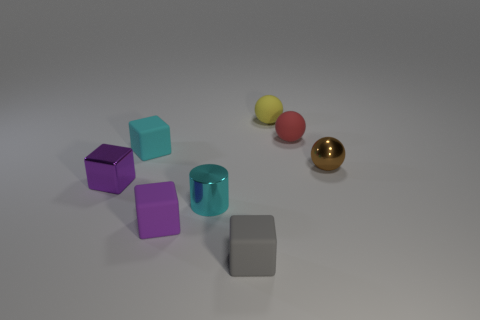How many purple blocks must be subtracted to get 1 purple blocks? 1 Add 1 tiny yellow objects. How many objects exist? 9 Subtract all matte balls. How many balls are left? 1 Subtract all spheres. How many objects are left? 5 Subtract all yellow spheres. How many spheres are left? 2 Subtract 3 blocks. How many blocks are left? 1 Subtract all red cylinders. Subtract all purple spheres. How many cylinders are left? 1 Subtract all brown cubes. How many brown cylinders are left? 0 Subtract all large cyan rubber cylinders. Subtract all small brown shiny objects. How many objects are left? 7 Add 1 tiny shiny things. How many tiny shiny things are left? 4 